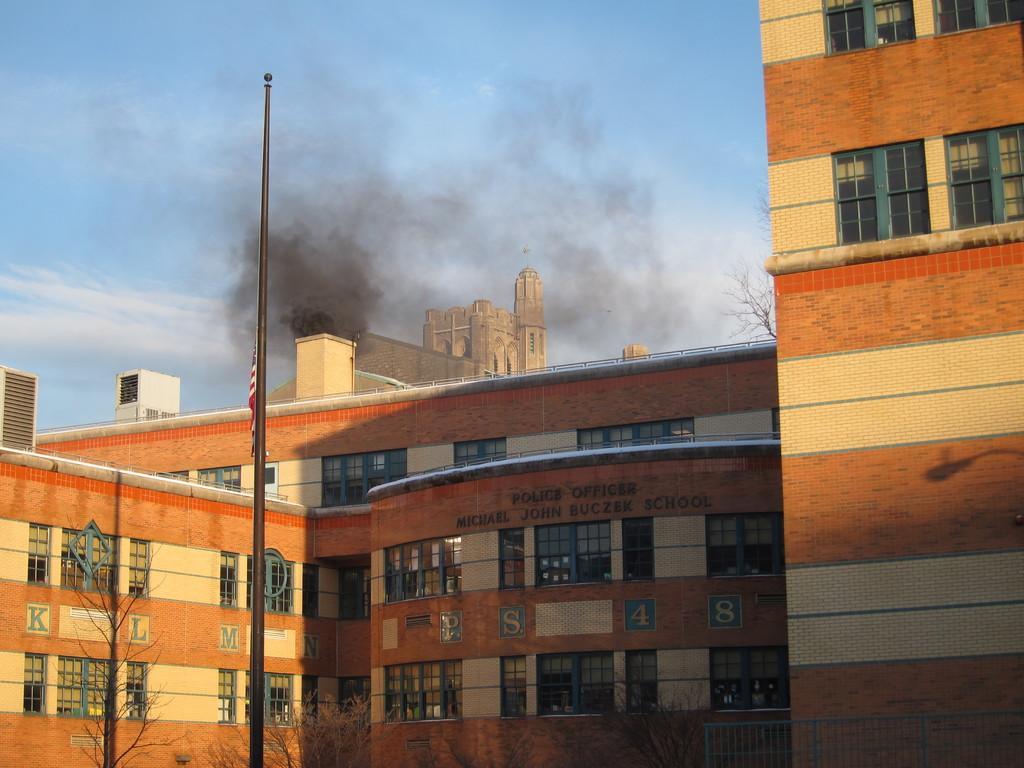Could you give a brief overview of what you see in this image? This picture is taken from the outside of the building. In this image, we can see a building. On the left side, we can see a pole. On the left side, we can also see shadow of a tree. On the left side, we can see a tree. On the right side, we can see the shadows of a street light. In the background, we can see a smoke, flag, building. At the top, we can see a sky which is a bit cloudy. 